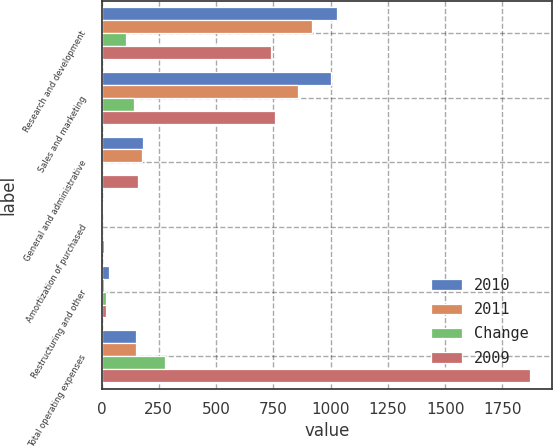Convert chart to OTSL. <chart><loc_0><loc_0><loc_500><loc_500><stacked_bar_chart><ecel><fcel>Research and development<fcel>Sales and marketing<fcel>General and administrative<fcel>Amortization of purchased<fcel>Restructuring and other<fcel>Total operating expenses<nl><fcel>2010<fcel>1026.8<fcel>1001.1<fcel>179.1<fcel>5.4<fcel>30.6<fcel>151.75<nl><fcel>2011<fcel>917.9<fcel>857.1<fcel>177.9<fcel>4.2<fcel>10.8<fcel>151.75<nl><fcel>Change<fcel>108.9<fcel>144<fcel>1.2<fcel>1.2<fcel>19.8<fcel>275.9<nl><fcel>2009<fcel>741.7<fcel>759.1<fcel>159.5<fcel>10.4<fcel>19.5<fcel>1872.5<nl></chart> 